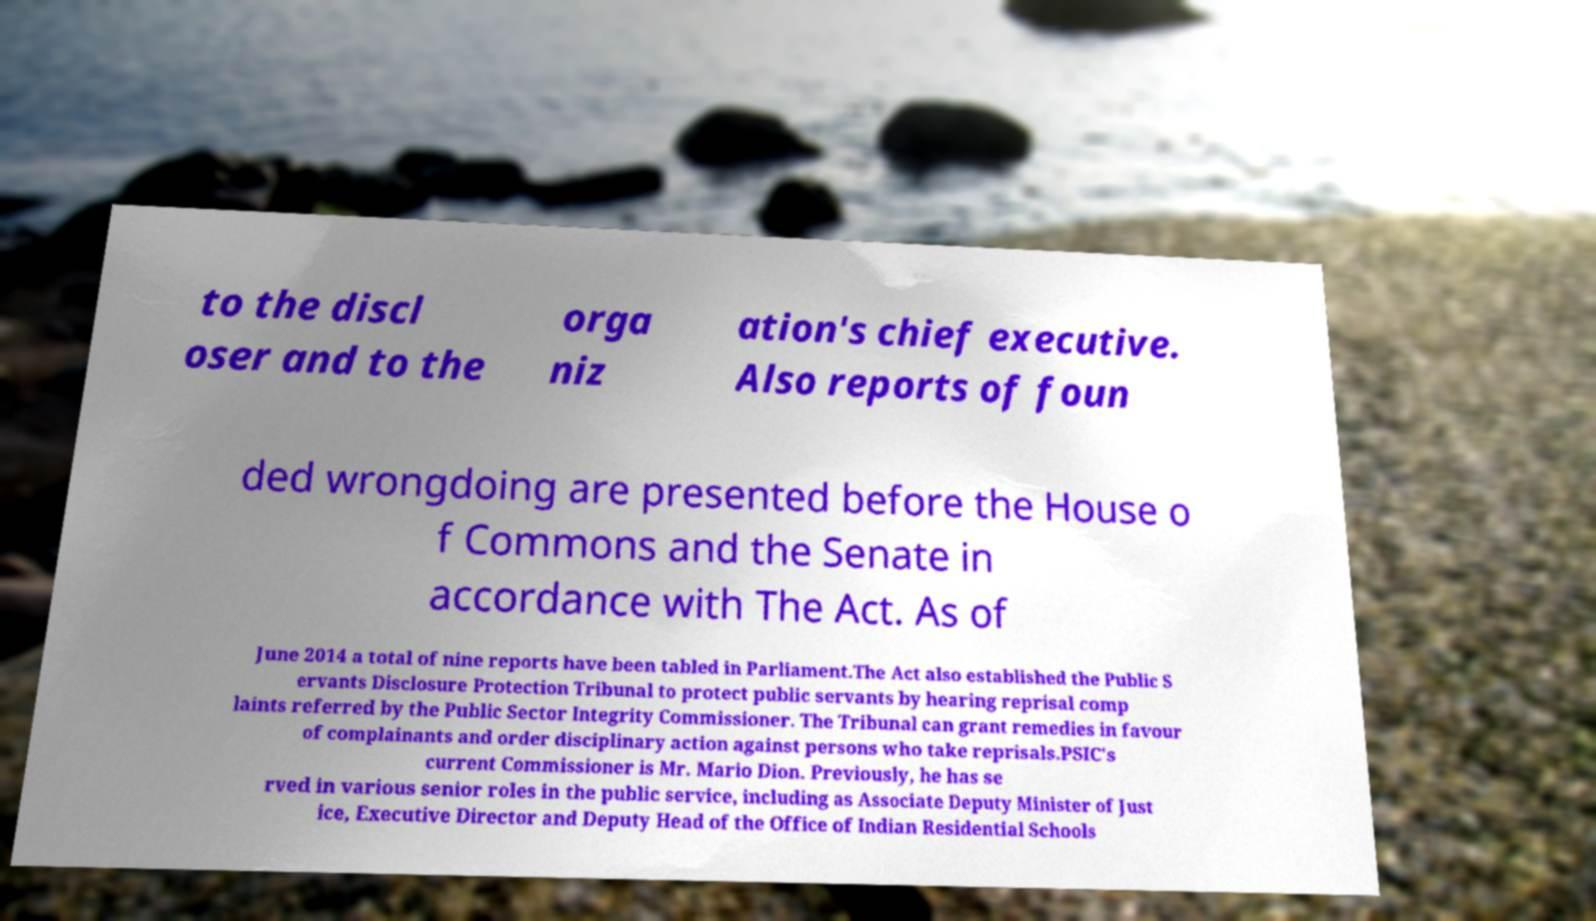For documentation purposes, I need the text within this image transcribed. Could you provide that? to the discl oser and to the orga niz ation's chief executive. Also reports of foun ded wrongdoing are presented before the House o f Commons and the Senate in accordance with The Act. As of June 2014 a total of nine reports have been tabled in Parliament.The Act also established the Public S ervants Disclosure Protection Tribunal to protect public servants by hearing reprisal comp laints referred by the Public Sector Integrity Commissioner. The Tribunal can grant remedies in favour of complainants and order disciplinary action against persons who take reprisals.PSIC's current Commissioner is Mr. Mario Dion. Previously, he has se rved in various senior roles in the public service, including as Associate Deputy Minister of Just ice, Executive Director and Deputy Head of the Office of Indian Residential Schools 